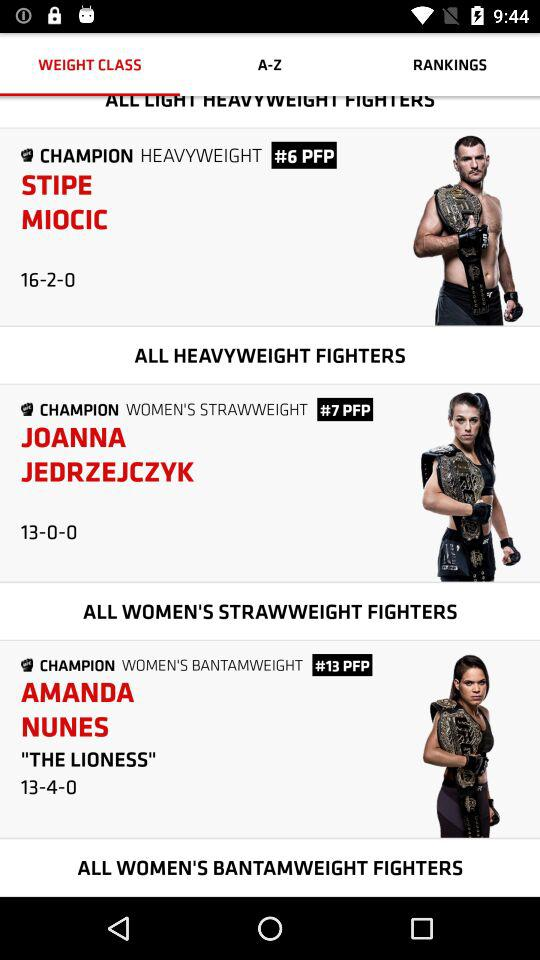Who is the champion of "WOMEN'S BANTAMWEIGHT"? Amanda Nunes, widely known as 'The Lioness', is the reigning champion in the Women's Bantamweight division of UFC, with a record of 13-4-0 as shown in the image. 